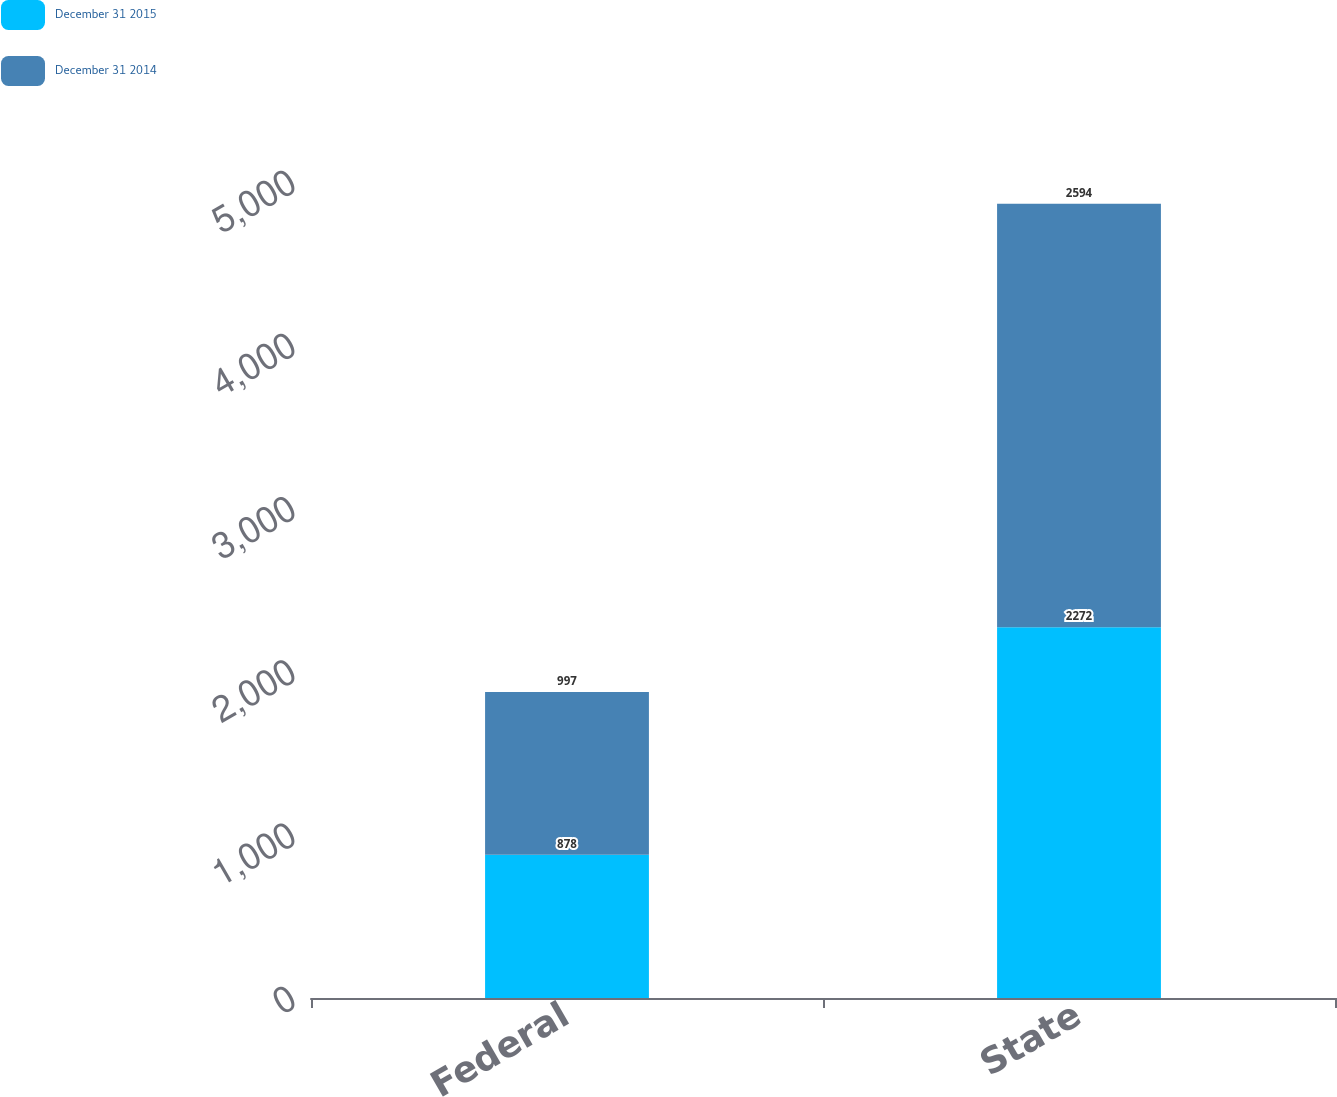Convert chart. <chart><loc_0><loc_0><loc_500><loc_500><stacked_bar_chart><ecel><fcel>Federal<fcel>State<nl><fcel>December 31 2015<fcel>878<fcel>2272<nl><fcel>December 31 2014<fcel>997<fcel>2594<nl></chart> 